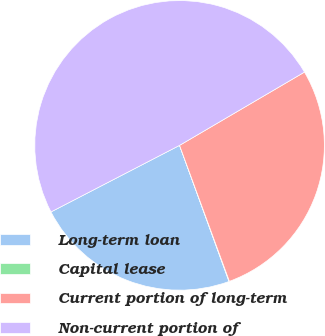<chart> <loc_0><loc_0><loc_500><loc_500><pie_chart><fcel>Long-term loan<fcel>Capital lease<fcel>Current portion of long-term<fcel>Non-current portion of<nl><fcel>22.94%<fcel>0.05%<fcel>27.85%<fcel>49.16%<nl></chart> 